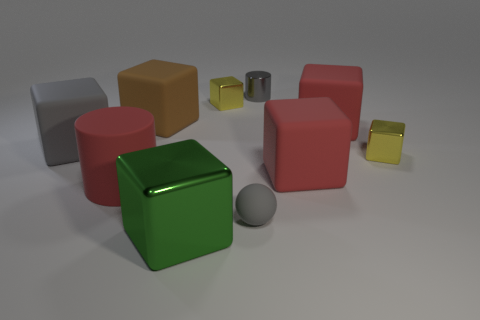How many metal things are either big green cubes or small yellow things?
Make the answer very short. 3. How many rubber things are the same color as the rubber cylinder?
Give a very brief answer. 2. There is a red block that is in front of the gray matte object that is on the left side of the large brown block; what is it made of?
Make the answer very short. Rubber. How big is the matte cylinder?
Keep it short and to the point. Large. How many purple matte blocks have the same size as the brown block?
Your response must be concise. 0. What number of other things have the same shape as the tiny gray metal thing?
Your answer should be very brief. 1. Are there the same number of small gray metal objects that are left of the tiny gray cylinder and red cubes?
Your answer should be very brief. No. There is a rubber thing that is the same size as the shiny cylinder; what is its shape?
Your response must be concise. Sphere. Are there any big gray rubber objects that have the same shape as the big metal thing?
Provide a short and direct response. Yes. There is a tiny thing that is to the right of the cylinder on the right side of the large red matte cylinder; is there a small ball that is in front of it?
Make the answer very short. Yes. 